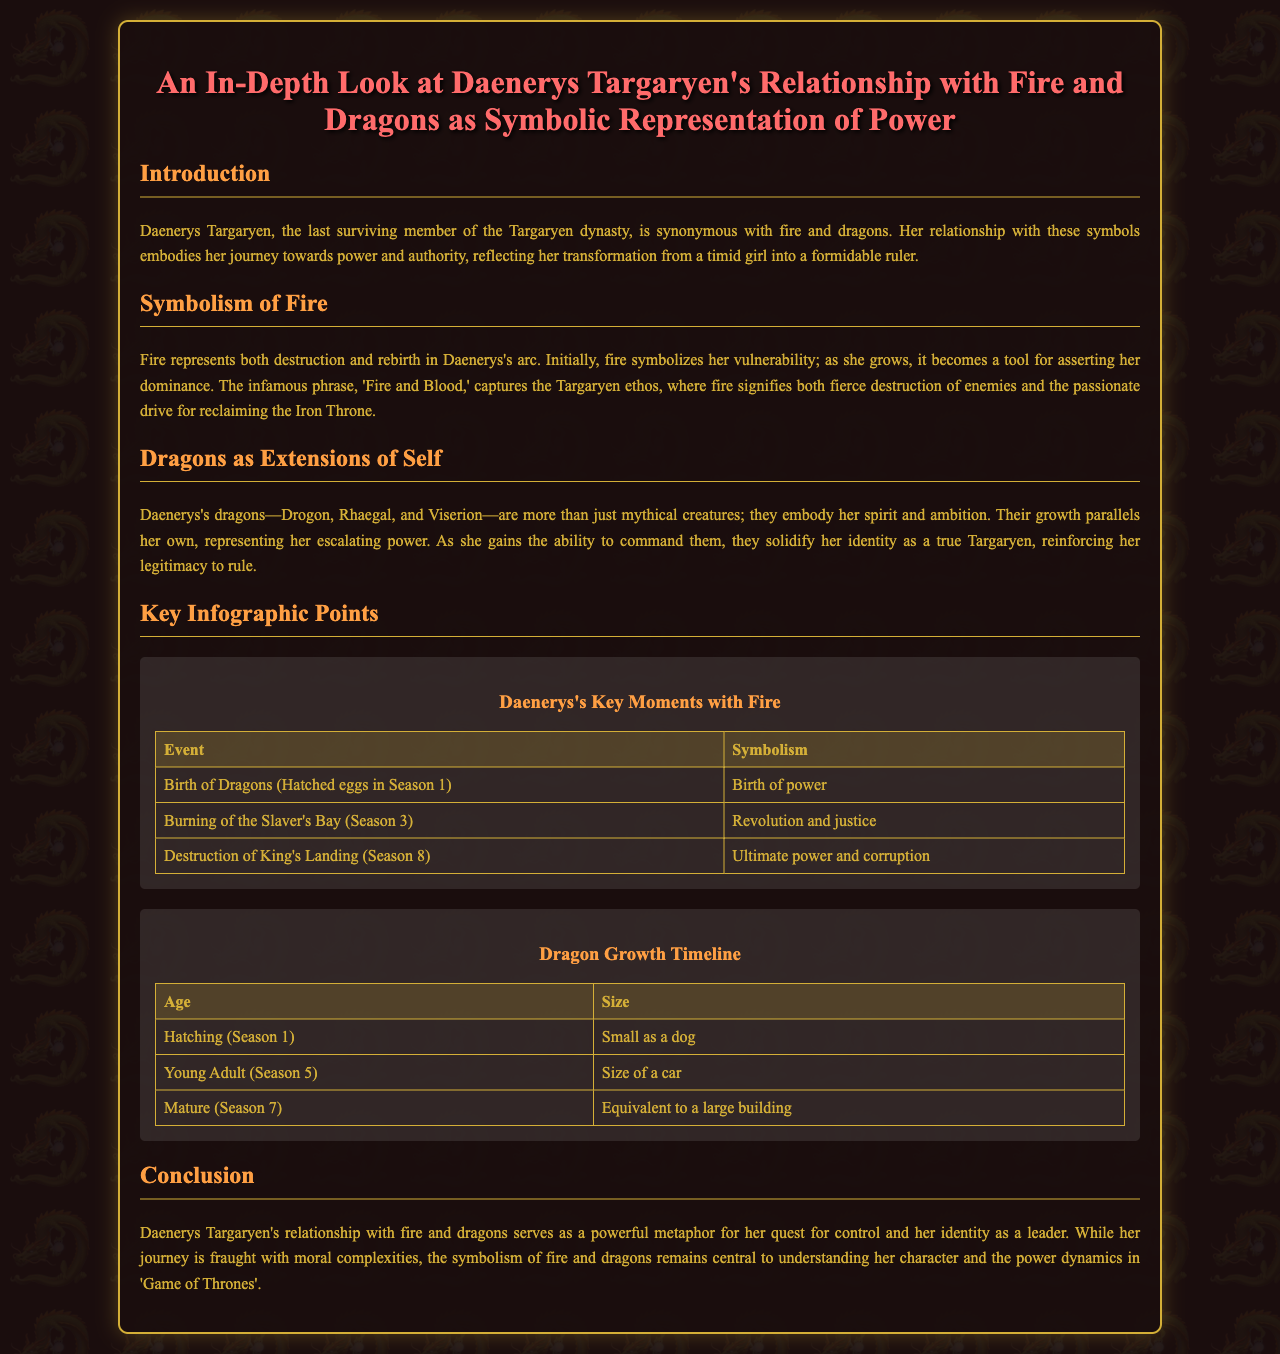What does fire symbolize in Daenerys's arc? Fire symbolizes both destruction and rebirth in Daenerys's arc, reflecting her transformative journey towards power.
Answer: Destruction and rebirth What is the name of Daenerys's dragon that is specifically mentioned first? The first dragon mentioned in the document is Drogon.
Answer: Drogon During which season did the burning of Slaver's Bay take place? The document states that the burning of Slaver's Bay occurred in Season 3.
Answer: Season 3 What size were the dragons when they hatched in Season 1? The document describes the dragons as being "small as a dog" when they hatched.
Answer: Small as a dog What key phrase encapsulates the Targaryen ethos? The phrase that encapsulates the Targaryen ethos is "Fire and Blood."
Answer: Fire and Blood How old were the dragons when they reached a mature size? The document indicates that the dragons reached maturity around Season 7.
Answer: Season 7 Which event represents the ultimate power and corruption in Daenerys’s journey? The destruction of King's Landing is cited as representing the ultimate power and corruption.
Answer: Destruction of King's Landing What do Daenerys's dragons represent in relation to her identity? Daenerys's dragons embody her spirit and ambition, reinforcing her legitimacy to rule.
Answer: Spirit and ambition 